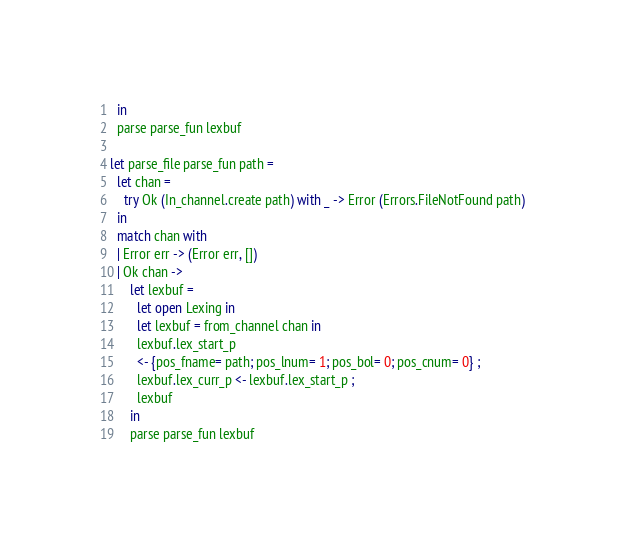<code> <loc_0><loc_0><loc_500><loc_500><_OCaml_>  in
  parse parse_fun lexbuf

let parse_file parse_fun path =
  let chan =
    try Ok (In_channel.create path) with _ -> Error (Errors.FileNotFound path)
  in
  match chan with
  | Error err -> (Error err, [])
  | Ok chan ->
      let lexbuf =
        let open Lexing in
        let lexbuf = from_channel chan in
        lexbuf.lex_start_p
        <- {pos_fname= path; pos_lnum= 1; pos_bol= 0; pos_cnum= 0} ;
        lexbuf.lex_curr_p <- lexbuf.lex_start_p ;
        lexbuf
      in
      parse parse_fun lexbuf
</code> 